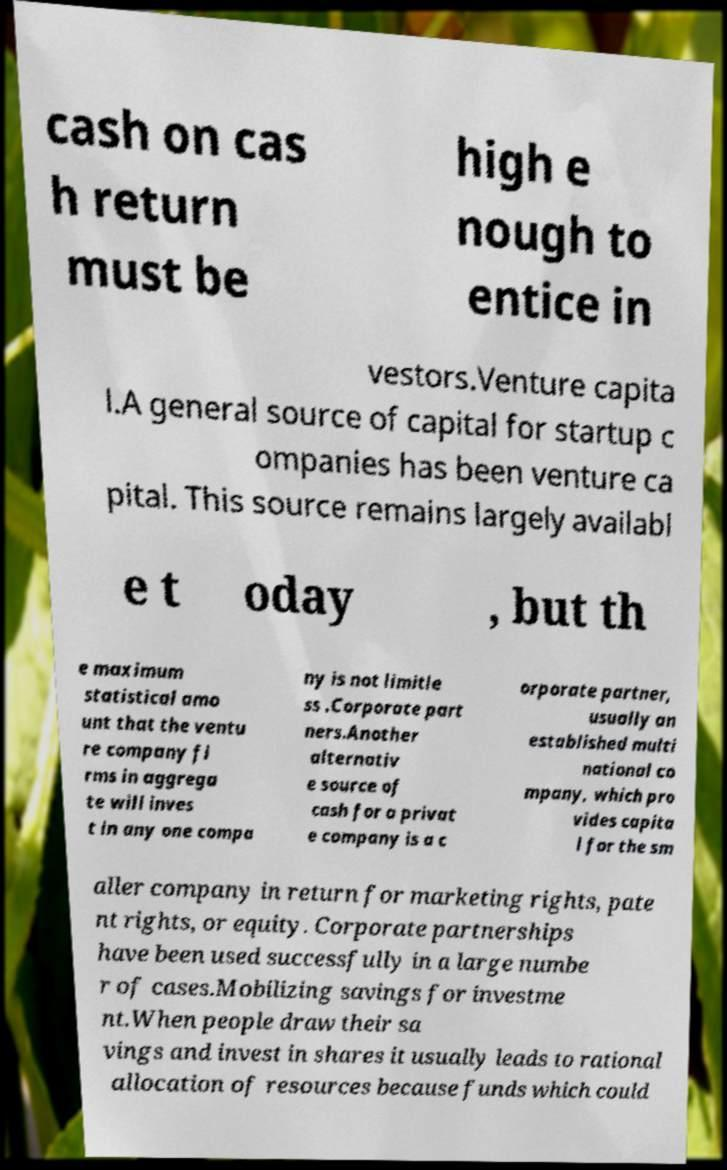There's text embedded in this image that I need extracted. Can you transcribe it verbatim? cash on cas h return must be high e nough to entice in vestors.Venture capita l.A general source of capital for startup c ompanies has been venture ca pital. This source remains largely availabl e t oday , but th e maximum statistical amo unt that the ventu re company fi rms in aggrega te will inves t in any one compa ny is not limitle ss .Corporate part ners.Another alternativ e source of cash for a privat e company is a c orporate partner, usually an established multi national co mpany, which pro vides capita l for the sm aller company in return for marketing rights, pate nt rights, or equity. Corporate partnerships have been used successfully in a large numbe r of cases.Mobilizing savings for investme nt.When people draw their sa vings and invest in shares it usually leads to rational allocation of resources because funds which could 